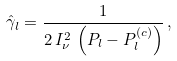<formula> <loc_0><loc_0><loc_500><loc_500>\hat { \gamma } _ { l } = \frac { 1 } { 2 \, I _ { \nu } ^ { 2 } \, \left ( P _ { l } - P _ { l } ^ { \left ( c \right ) } \right ) } \, ,</formula> 